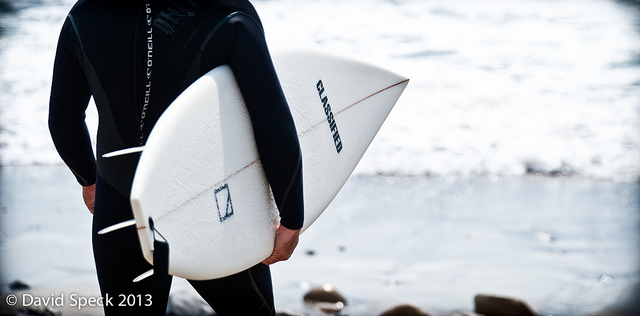<image>Whose surfboard is that? I don't know whose surfboard that is. It could belong to the man in black, David Speck, the surfer, or the person holding it. Whose surfboard is that? I don't know whose surfboard it is. It can be David's or belongs to the surfer. 